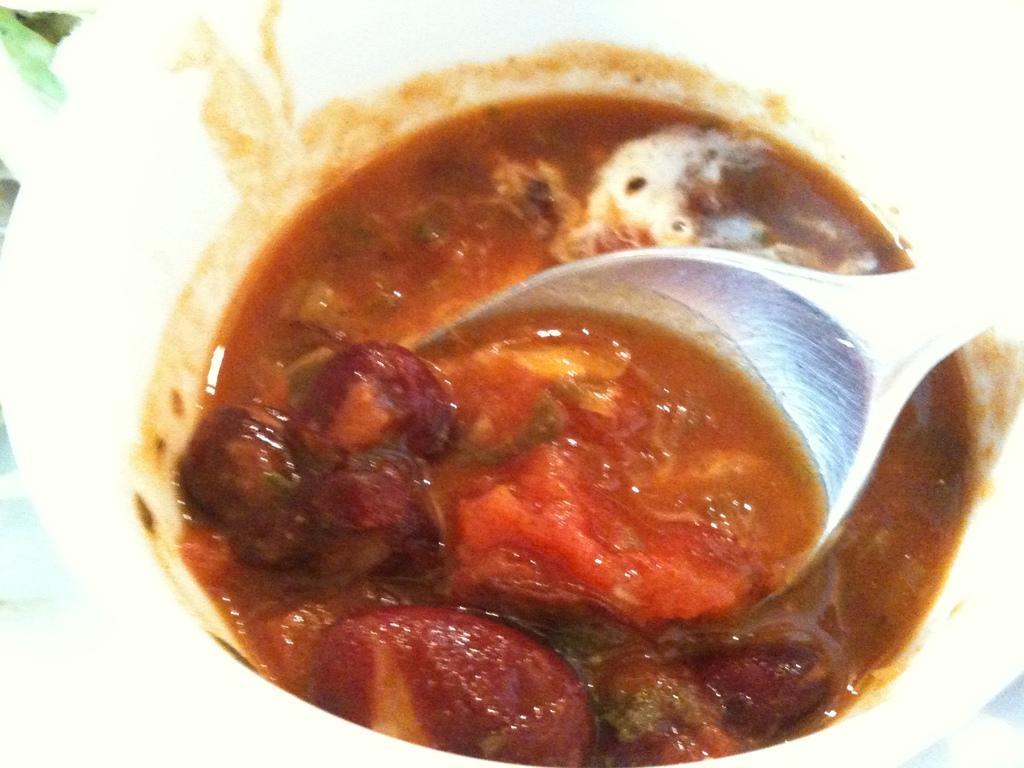Can you describe this image briefly? In this image we can see an object looks like a bowl and some food items and a spoon in it. 